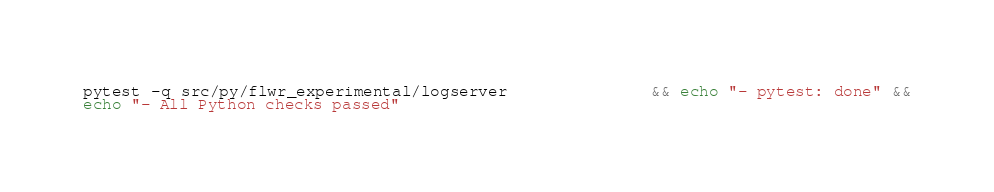<code> <loc_0><loc_0><loc_500><loc_500><_Bash_>pytest -q src/py/flwr_experimental/logserver               && echo "- pytest: done" &&
echo "- All Python checks passed"
</code> 